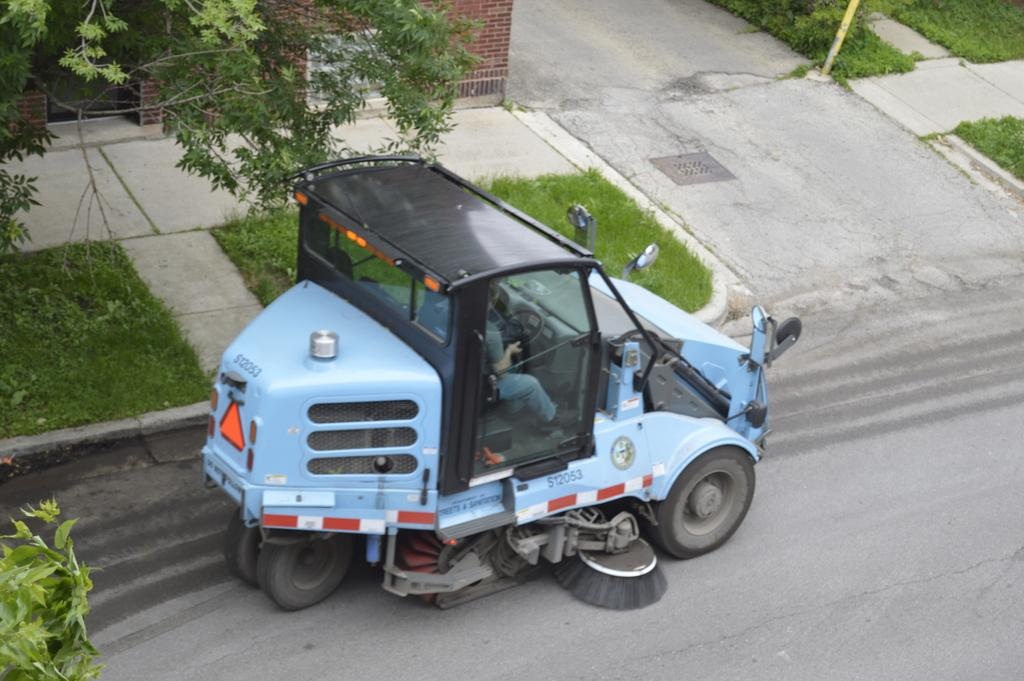What is the person in the image doing? The person is riding a vehicle on the road. What type of natural environment can be seen in the image? There is grass visible in the image. What is the main feature of the image? The main feature of the image is the road. What structures are present in the image? Walkways, a wall, and a pole are visible in the image. What type of vegetation is present in the image? Leaves and stems are present in the image. How many dolls are sitting on the wall in the image? There are no dolls present in the image; the wall is a structure and not a place for dolls. 